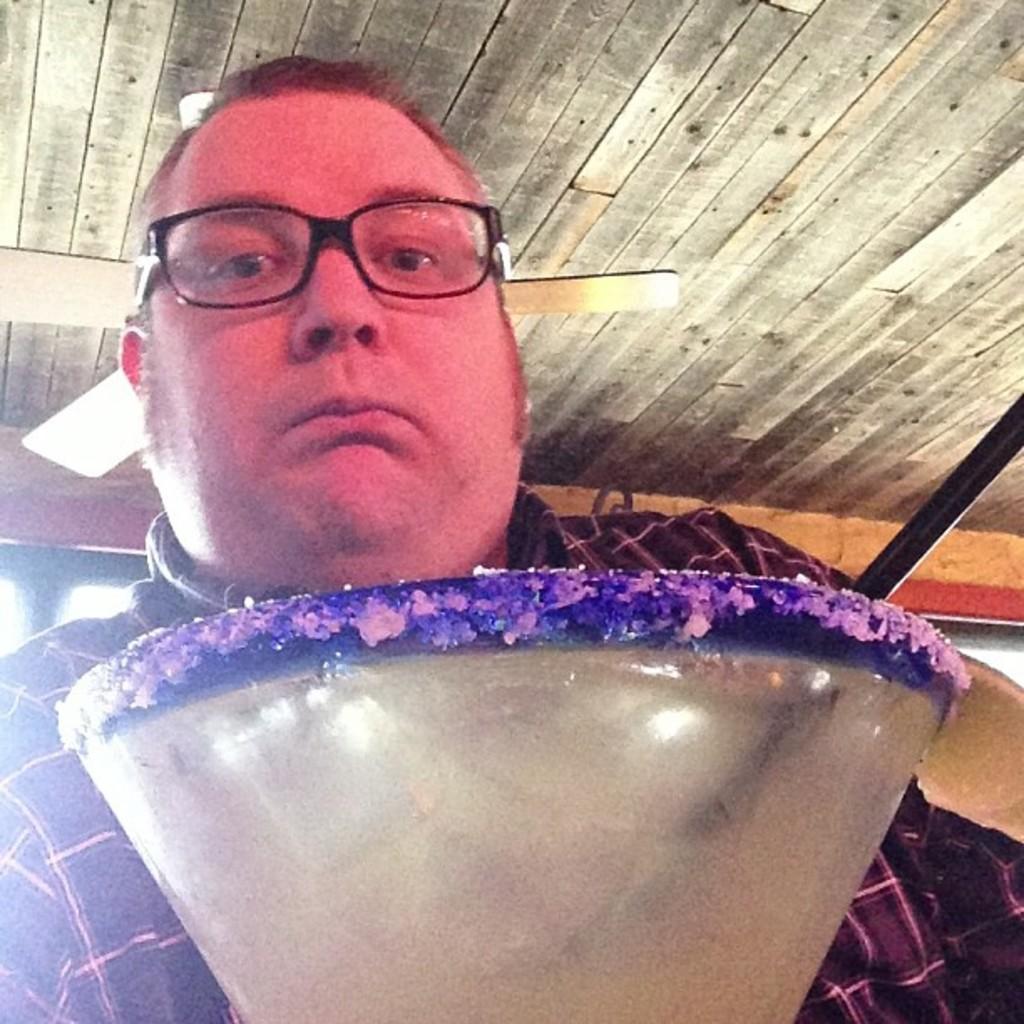How would you summarize this image in a sentence or two? In this image I can see the person with the dress and specs. In-front of the person I can see an object which is in cream, blue and purple color. At the top I can see the fan to the wooden ceiling. 